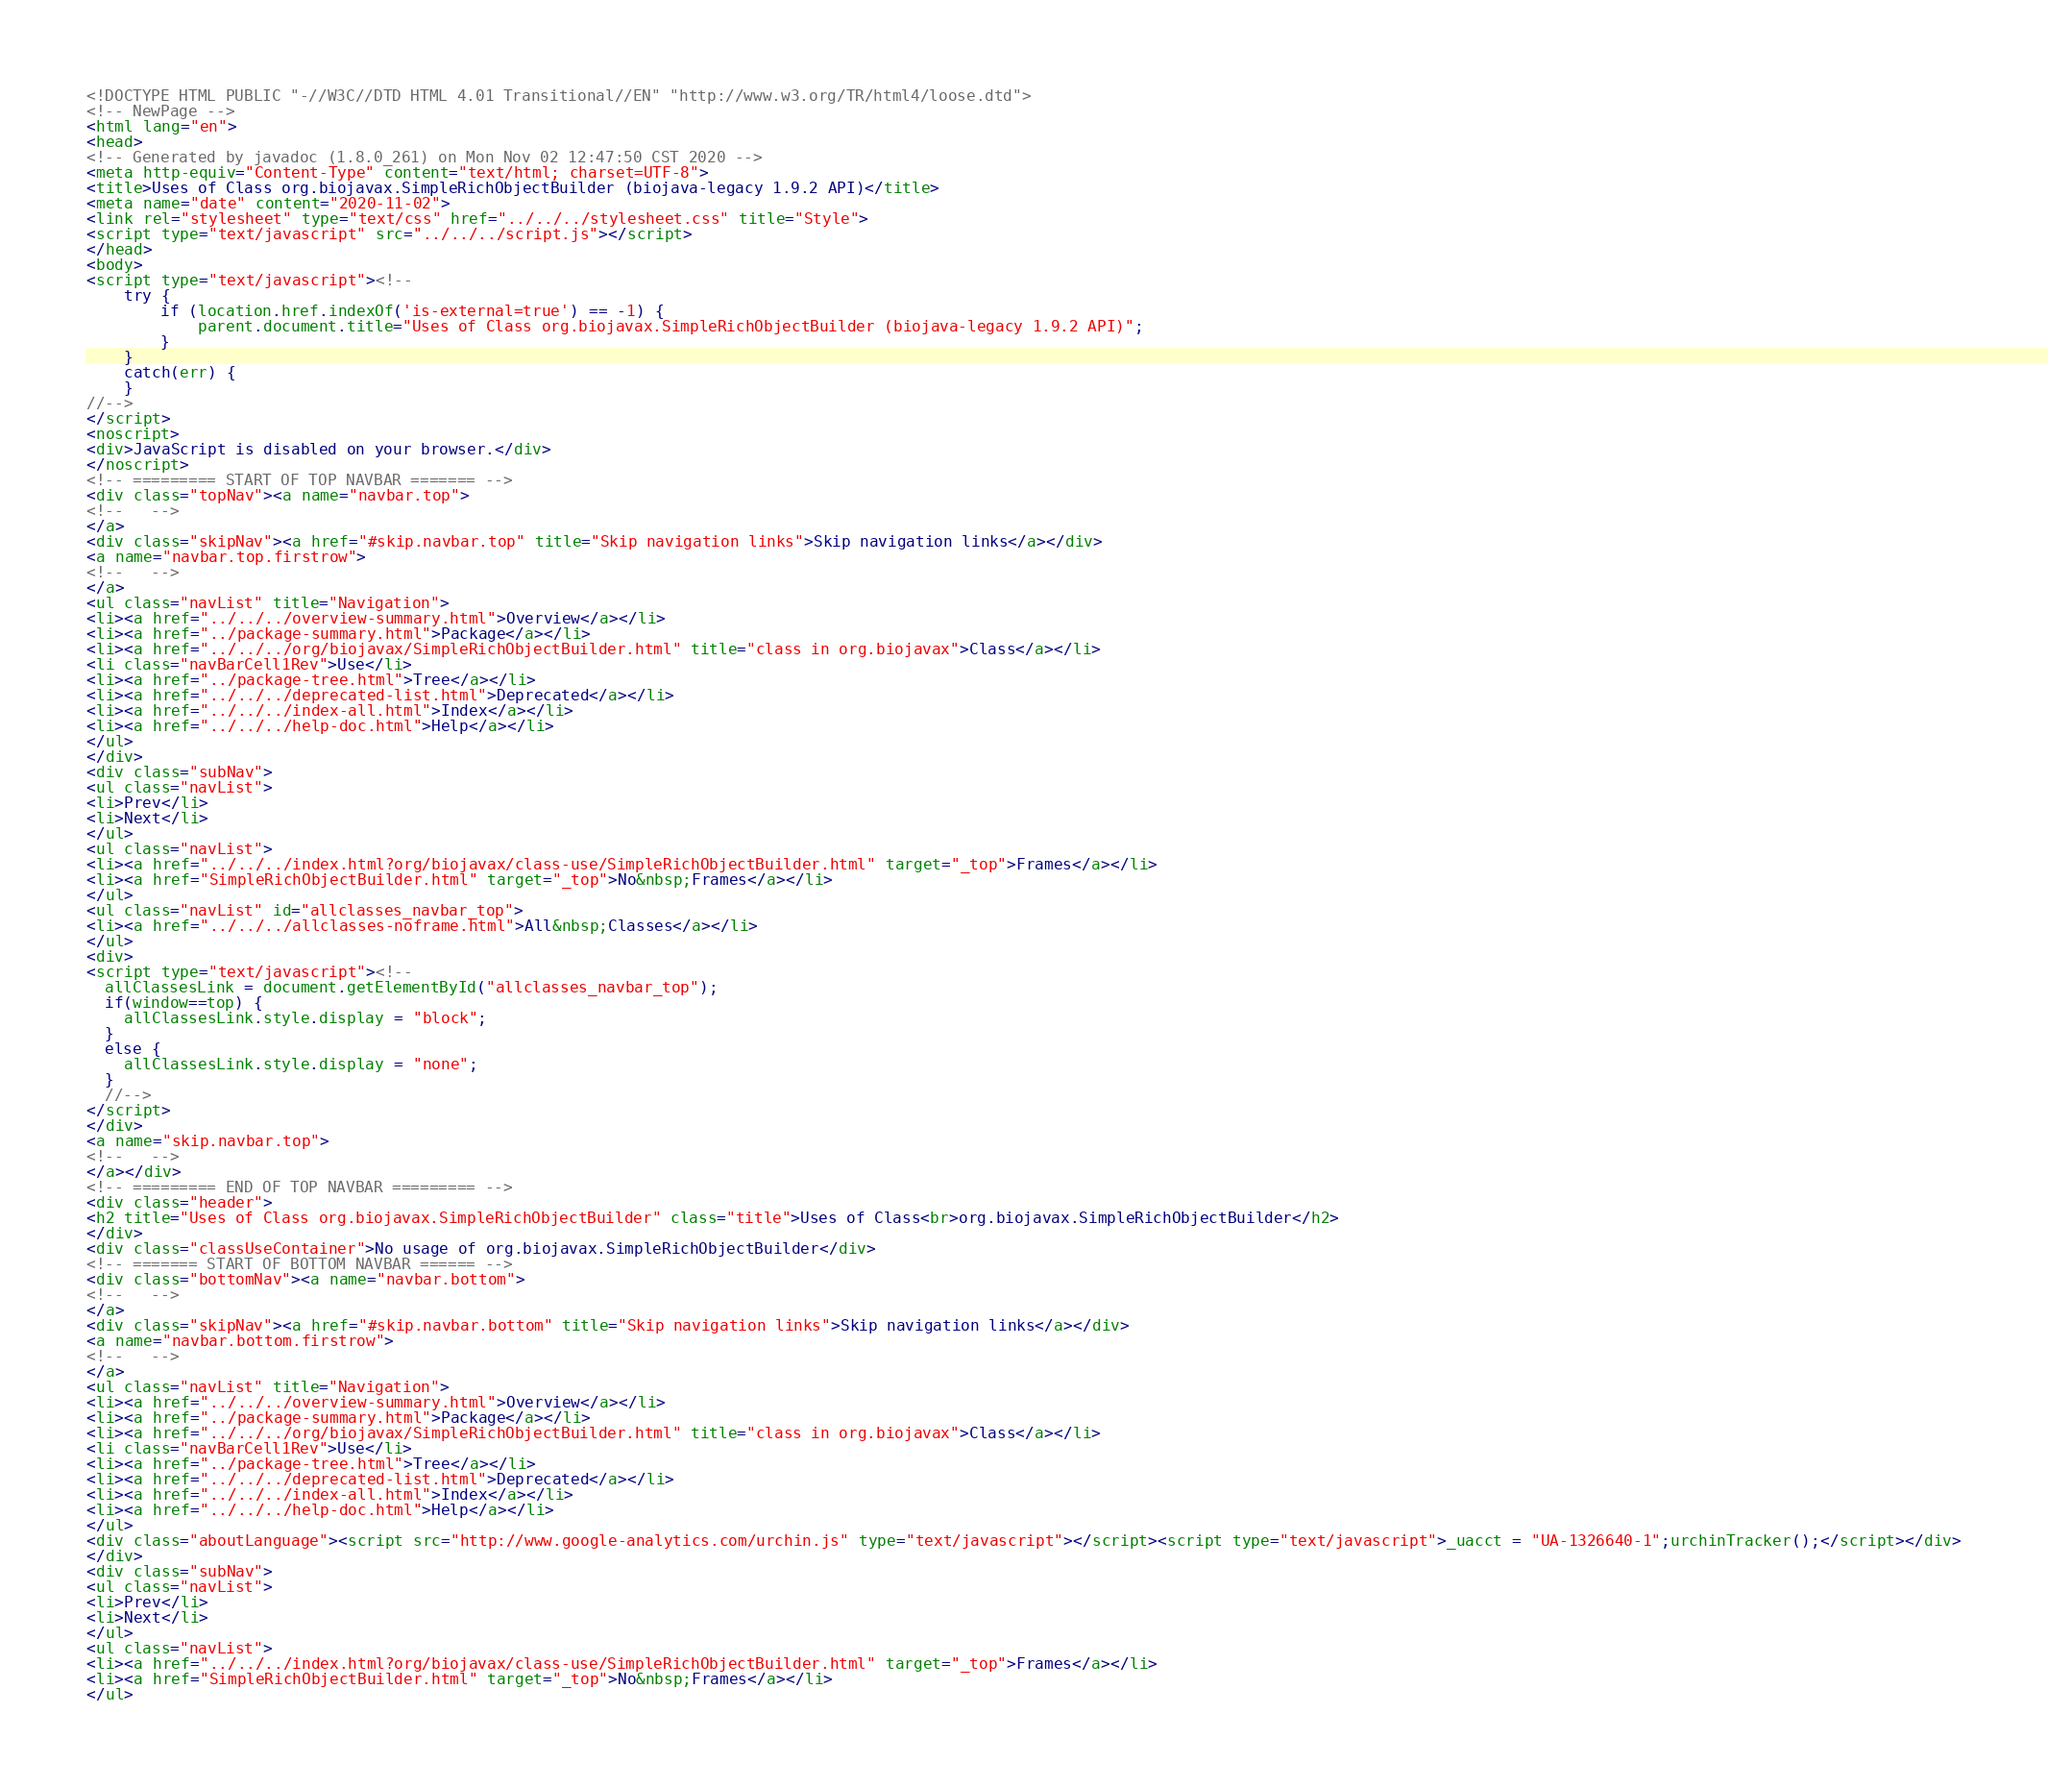Convert code to text. <code><loc_0><loc_0><loc_500><loc_500><_HTML_><!DOCTYPE HTML PUBLIC "-//W3C//DTD HTML 4.01 Transitional//EN" "http://www.w3.org/TR/html4/loose.dtd">
<!-- NewPage -->
<html lang="en">
<head>
<!-- Generated by javadoc (1.8.0_261) on Mon Nov 02 12:47:50 CST 2020 -->
<meta http-equiv="Content-Type" content="text/html; charset=UTF-8">
<title>Uses of Class org.biojavax.SimpleRichObjectBuilder (biojava-legacy 1.9.2 API)</title>
<meta name="date" content="2020-11-02">
<link rel="stylesheet" type="text/css" href="../../../stylesheet.css" title="Style">
<script type="text/javascript" src="../../../script.js"></script>
</head>
<body>
<script type="text/javascript"><!--
    try {
        if (location.href.indexOf('is-external=true') == -1) {
            parent.document.title="Uses of Class org.biojavax.SimpleRichObjectBuilder (biojava-legacy 1.9.2 API)";
        }
    }
    catch(err) {
    }
//-->
</script>
<noscript>
<div>JavaScript is disabled on your browser.</div>
</noscript>
<!-- ========= START OF TOP NAVBAR ======= -->
<div class="topNav"><a name="navbar.top">
<!--   -->
</a>
<div class="skipNav"><a href="#skip.navbar.top" title="Skip navigation links">Skip navigation links</a></div>
<a name="navbar.top.firstrow">
<!--   -->
</a>
<ul class="navList" title="Navigation">
<li><a href="../../../overview-summary.html">Overview</a></li>
<li><a href="../package-summary.html">Package</a></li>
<li><a href="../../../org/biojavax/SimpleRichObjectBuilder.html" title="class in org.biojavax">Class</a></li>
<li class="navBarCell1Rev">Use</li>
<li><a href="../package-tree.html">Tree</a></li>
<li><a href="../../../deprecated-list.html">Deprecated</a></li>
<li><a href="../../../index-all.html">Index</a></li>
<li><a href="../../../help-doc.html">Help</a></li>
</ul>
</div>
<div class="subNav">
<ul class="navList">
<li>Prev</li>
<li>Next</li>
</ul>
<ul class="navList">
<li><a href="../../../index.html?org/biojavax/class-use/SimpleRichObjectBuilder.html" target="_top">Frames</a></li>
<li><a href="SimpleRichObjectBuilder.html" target="_top">No&nbsp;Frames</a></li>
</ul>
<ul class="navList" id="allclasses_navbar_top">
<li><a href="../../../allclasses-noframe.html">All&nbsp;Classes</a></li>
</ul>
<div>
<script type="text/javascript"><!--
  allClassesLink = document.getElementById("allclasses_navbar_top");
  if(window==top) {
    allClassesLink.style.display = "block";
  }
  else {
    allClassesLink.style.display = "none";
  }
  //-->
</script>
</div>
<a name="skip.navbar.top">
<!--   -->
</a></div>
<!-- ========= END OF TOP NAVBAR ========= -->
<div class="header">
<h2 title="Uses of Class org.biojavax.SimpleRichObjectBuilder" class="title">Uses of Class<br>org.biojavax.SimpleRichObjectBuilder</h2>
</div>
<div class="classUseContainer">No usage of org.biojavax.SimpleRichObjectBuilder</div>
<!-- ======= START OF BOTTOM NAVBAR ====== -->
<div class="bottomNav"><a name="navbar.bottom">
<!--   -->
</a>
<div class="skipNav"><a href="#skip.navbar.bottom" title="Skip navigation links">Skip navigation links</a></div>
<a name="navbar.bottom.firstrow">
<!--   -->
</a>
<ul class="navList" title="Navigation">
<li><a href="../../../overview-summary.html">Overview</a></li>
<li><a href="../package-summary.html">Package</a></li>
<li><a href="../../../org/biojavax/SimpleRichObjectBuilder.html" title="class in org.biojavax">Class</a></li>
<li class="navBarCell1Rev">Use</li>
<li><a href="../package-tree.html">Tree</a></li>
<li><a href="../../../deprecated-list.html">Deprecated</a></li>
<li><a href="../../../index-all.html">Index</a></li>
<li><a href="../../../help-doc.html">Help</a></li>
</ul>
<div class="aboutLanguage"><script src="http://www.google-analytics.com/urchin.js" type="text/javascript"></script><script type="text/javascript">_uacct = "UA-1326640-1";urchinTracker();</script></div>
</div>
<div class="subNav">
<ul class="navList">
<li>Prev</li>
<li>Next</li>
</ul>
<ul class="navList">
<li><a href="../../../index.html?org/biojavax/class-use/SimpleRichObjectBuilder.html" target="_top">Frames</a></li>
<li><a href="SimpleRichObjectBuilder.html" target="_top">No&nbsp;Frames</a></li>
</ul></code> 